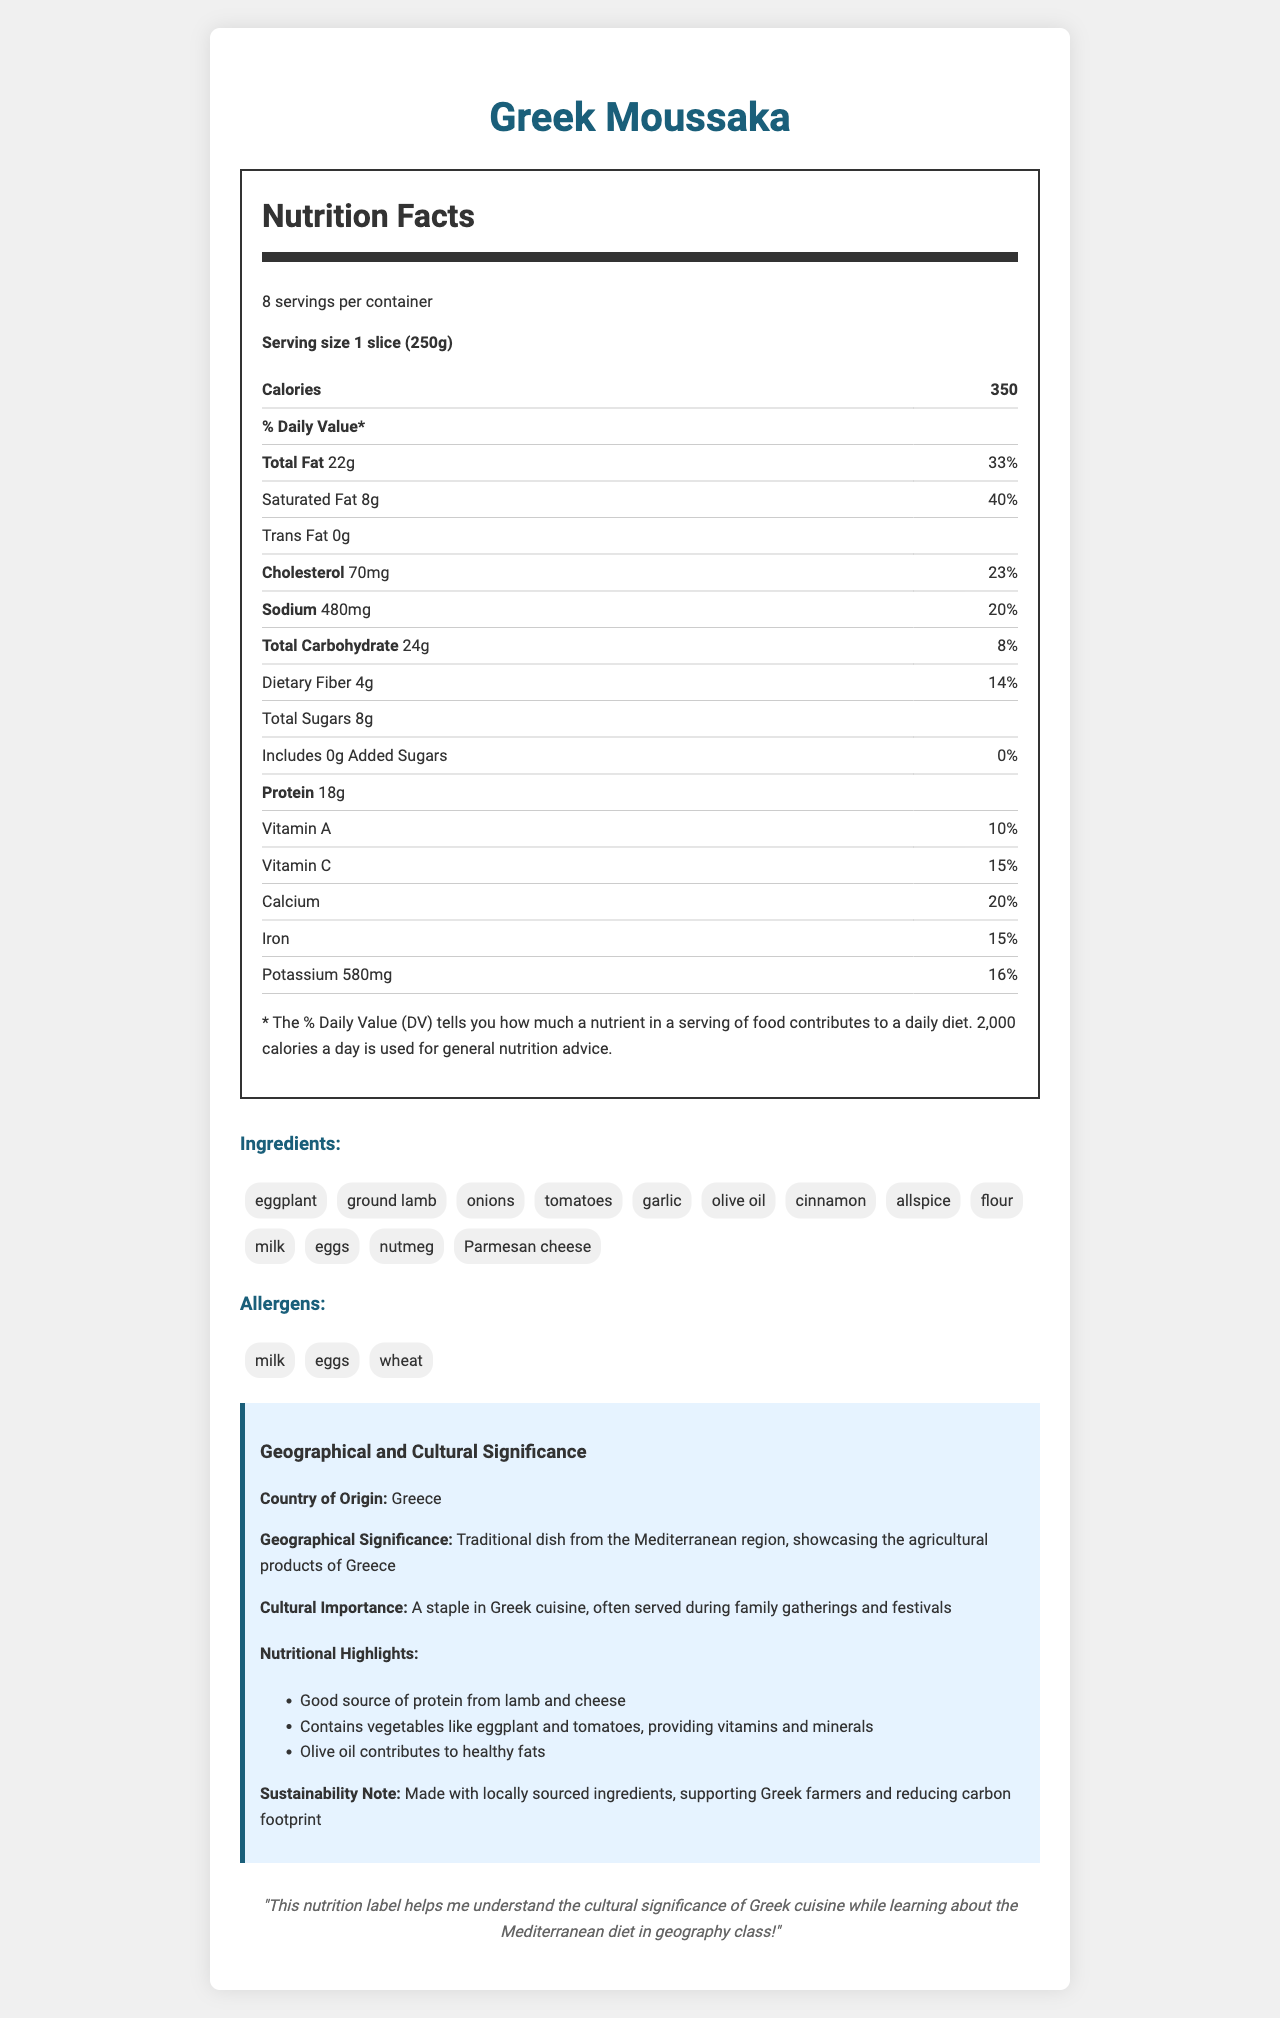what is the serving size for Greek Moussaka? The document specifies the serving size as "1 slice (250g)".
Answer: 1 slice (250g) how many servings are in one container? The document states that there are 8 servings per container.
Answer: 8 how many grams of total fat are in one serving? According to the nutrition facts, one serving contains 22 grams of total fat.
Answer: 22 grams what percentage of the daily value of Vitamin C does one serving provide? The nutrition facts indicate that one serving provides 15% of the daily value for Vitamin C.
Answer: 15% what is the main protein source in Greek Moussaka? A. Eggplant B. Ground lamb C. Tomatoes The nutritional highlights mention that the dish is a good source of protein from lamb and cheese, indicating ground lamb as the main protein source.
Answer: B. Ground lamb which ingredient contributes to the healthy fats in the dish? A. Eggplant B. Parmesan cheese C. Olive oil The nutritional highlights specifically point out that olive oil contributes to healthy fats.
Answer: C. Olive oil is there any trans fat in Greek Moussaka? The nutrition facts label shows 0 grams of trans fat per serving.
Answer: No does the dish contain any added sugars? The nutrition facts indicate that there are 0 grams of added sugars in the dish.
Answer: No does Greek Moussaka include any allergens? The document lists milk, eggs, and wheat as allergens.
Answer: Yes summarize the cultural and nutritional information provided in the document. The document provides detailed cultural and nutritional information about Greek Moussaka, emphasizing its significance in Greek cuisine and its nutritional benefits.
Answer: Greek Moussaka is a traditional dish from Greece, showcasing its agricultural products. It is a staple in Greek cuisine, often served during family gatherings and festivals. Nutritionally, it's a good source of protein from lamb and cheese, contains vegetables like eggplant and tomatoes, and uses olive oil for healthy fats. The dish supports sustainability by using locally sourced ingredients. what is the percentage of daily value of dietary fiber in one serving? The nutrition facts label indicates 4 grams of dietary fiber, which is 14% of the daily value (4/28*100 = 14%).
Answer: 14% how many grams of protein are in one serving? The nutrition facts indicate that one serving contains 18 grams of protein.
Answer: 18 grams is Greek Moussaka high in sodium? The document shows that one serving contains 480mg of sodium, which is 21% of the daily value (480/2300*100 = 21%), indicating a relatively high sodium content.
Answer: Yes how does the dish support sustainability? The sustainability note in the document states that the dish is made with locally sourced ingredients, which supports Greek farmers and reduces the carbon footprint.
Answer: Made with locally sourced ingredients, supporting Greek farmers and reducing carbon footprint how much potassium does one serving of Greek Moussaka contain? The nutrition facts label shows that one serving contains 580 mg of potassium.
Answer: 580 mg how many calories does one serving of Greek Moussaka have? The document specifies that one serving contains 350 calories.
Answer: 350 calories what geographical region does Greek Moussaka originate from? The document states that the dish originates from Greece and has geographical significance in the Mediterranean region.
Answer: Greece does the dish contain any nutmeg? The ingredients list includes nutmeg.
Answer: Yes who is the most famous Greek chef? The document does not provide any information about chefs, so this question cannot be answered based on the visual information in the document.
Answer: Not enough information 